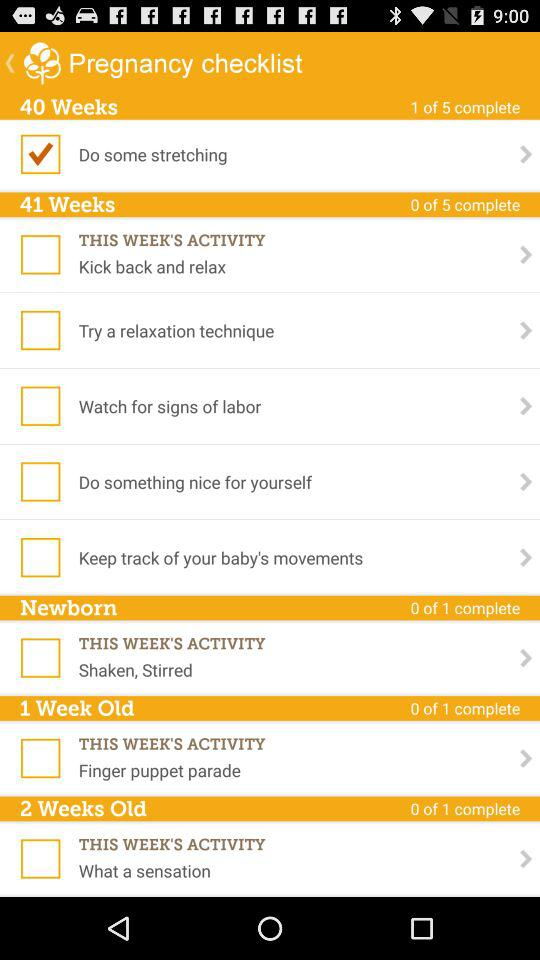Define the status of this week activity?
When the provided information is insufficient, respond with <no answer>. <no answer> 